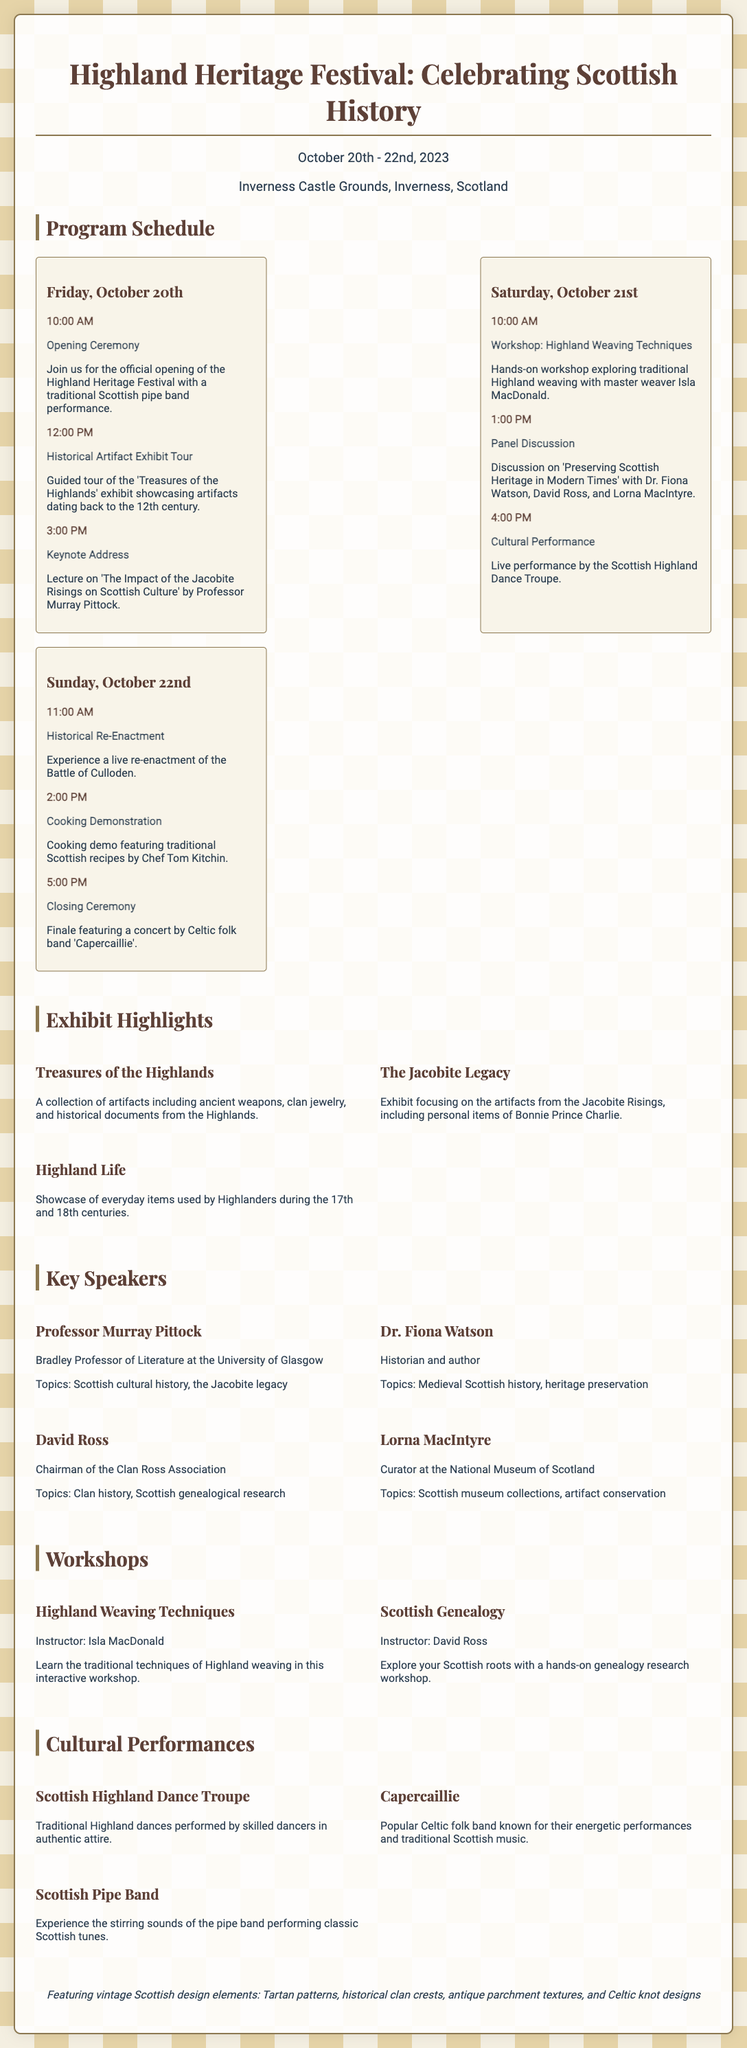What are the festival dates? The festival is scheduled from October 20th to October 22nd, 2023.
Answer: October 20th - 22nd, 2023 Where is the festival taking place? The festival will be held at Inverness Castle Grounds in Inverness, Scotland.
Answer: Inverness Castle Grounds, Inverness, Scotland Who is the keynote speaker? The keynote address will be given by Professor Murray Pittock.
Answer: Professor Murray Pittock What time does the closing ceremony start? The closing ceremony is scheduled to begin at 5:00 PM on October 22nd.
Answer: 5:00 PM How many historical exhibits are highlighted? There are three highlighted exhibits mentioned in the document.
Answer: Three What topic will Dr. Fiona Watson discuss? Dr. Fiona Watson will discuss "Medieval Scottish history, heritage preservation."
Answer: Medieval Scottish history, heritage preservation What is the title of the cooking demonstration? The title of the cooking demonstration is "Cooking Demonstration."
Answer: Cooking Demonstration Which cultural performance features a pipe band? The Scottish Pipe Band is mentioned as a cultural performance at the festival.
Answer: Scottish Pipe Band What kind of design motifs are featured in the document? The document features vintage Scottish design elements, including Tartan patterns and Celtic knot designs.
Answer: Tartan patterns, Celtic knot designs 